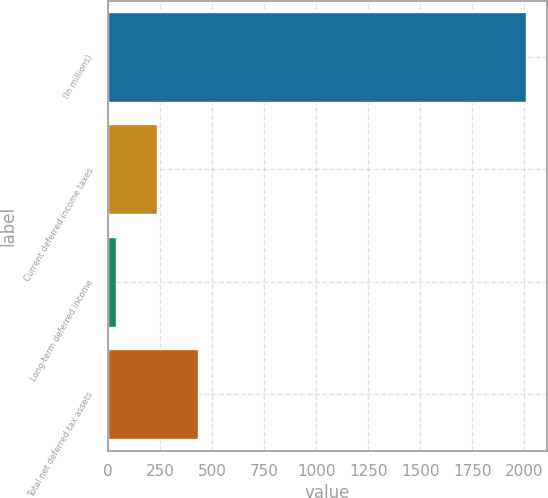Convert chart. <chart><loc_0><loc_0><loc_500><loc_500><bar_chart><fcel>(In millions)<fcel>Current deferred income taxes<fcel>Long-term deferred income<fcel>Total net deferred tax assets<nl><fcel>2009<fcel>233.3<fcel>36<fcel>430.6<nl></chart> 